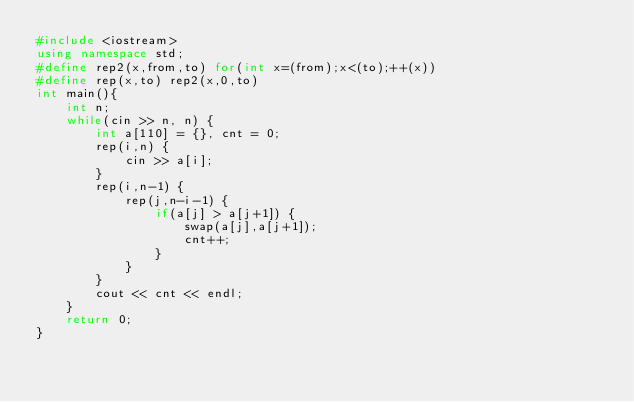Convert code to text. <code><loc_0><loc_0><loc_500><loc_500><_C++_>#include <iostream>
using namespace std;
#define rep2(x,from,to) for(int x=(from);x<(to);++(x))
#define rep(x,to) rep2(x,0,to)
int main(){
	int n;
	while(cin >> n, n) {
		int a[110] = {}, cnt = 0;
		rep(i,n) {
			cin >> a[i];
		}
		rep(i,n-1) {
			rep(j,n-i-1) {
				if(a[j] > a[j+1]) {
					swap(a[j],a[j+1]);
					cnt++;
				}
			}
		}
		cout << cnt << endl;
	}
    return 0;
}</code> 